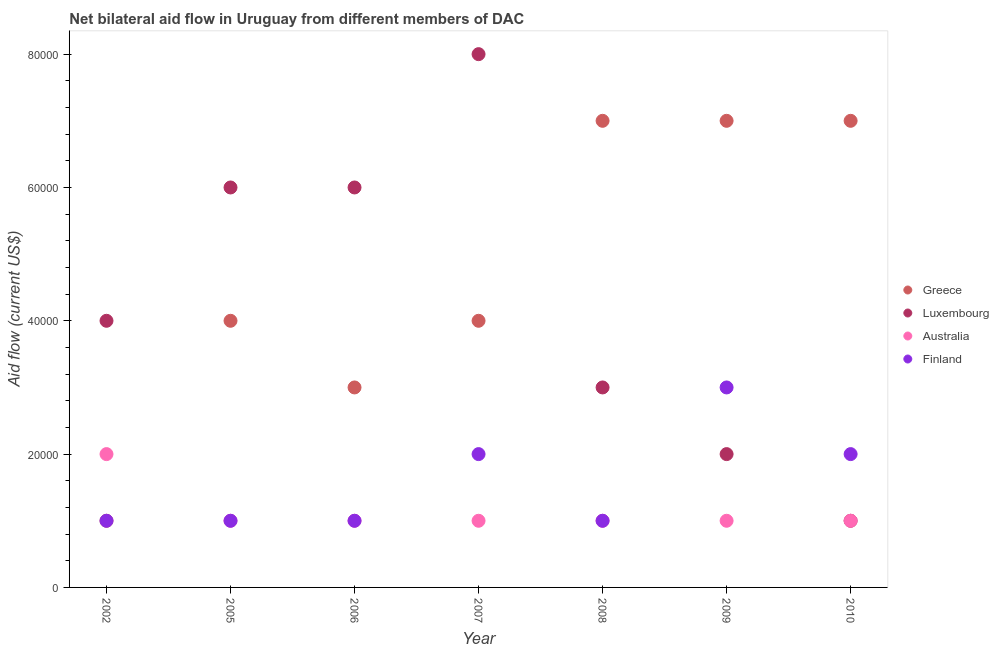What is the amount of aid given by greece in 2005?
Your response must be concise. 4.00e+04. Across all years, what is the maximum amount of aid given by australia?
Provide a succinct answer. 2.00e+04. Across all years, what is the minimum amount of aid given by luxembourg?
Give a very brief answer. 10000. What is the total amount of aid given by finland in the graph?
Your answer should be compact. 1.10e+05. What is the difference between the amount of aid given by luxembourg in 2007 and that in 2010?
Keep it short and to the point. 7.00e+04. What is the difference between the amount of aid given by finland in 2007 and the amount of aid given by greece in 2009?
Your answer should be compact. -5.00e+04. What is the average amount of aid given by luxembourg per year?
Make the answer very short. 4.29e+04. In the year 2002, what is the difference between the amount of aid given by luxembourg and amount of aid given by greece?
Your answer should be very brief. 3.00e+04. What is the ratio of the amount of aid given by greece in 2002 to that in 2006?
Make the answer very short. 0.33. Is the difference between the amount of aid given by greece in 2002 and 2005 greater than the difference between the amount of aid given by luxembourg in 2002 and 2005?
Offer a terse response. No. What is the difference between the highest and the lowest amount of aid given by greece?
Make the answer very short. 6.00e+04. Is the sum of the amount of aid given by finland in 2002 and 2009 greater than the maximum amount of aid given by australia across all years?
Make the answer very short. Yes. Is the amount of aid given by australia strictly greater than the amount of aid given by luxembourg over the years?
Offer a terse response. No. Is the amount of aid given by finland strictly less than the amount of aid given by luxembourg over the years?
Ensure brevity in your answer.  No. Are the values on the major ticks of Y-axis written in scientific E-notation?
Ensure brevity in your answer.  No. Does the graph contain any zero values?
Your answer should be compact. No. Does the graph contain grids?
Provide a short and direct response. No. How many legend labels are there?
Make the answer very short. 4. How are the legend labels stacked?
Offer a terse response. Vertical. What is the title of the graph?
Offer a terse response. Net bilateral aid flow in Uruguay from different members of DAC. What is the label or title of the Y-axis?
Give a very brief answer. Aid flow (current US$). What is the Aid flow (current US$) of Luxembourg in 2002?
Provide a succinct answer. 4.00e+04. What is the Aid flow (current US$) of Australia in 2002?
Your response must be concise. 2.00e+04. What is the Aid flow (current US$) of Australia in 2005?
Keep it short and to the point. 10000. What is the Aid flow (current US$) of Finland in 2005?
Keep it short and to the point. 10000. What is the Aid flow (current US$) in Luxembourg in 2006?
Your response must be concise. 6.00e+04. What is the Aid flow (current US$) of Australia in 2006?
Your answer should be compact. 10000. What is the Aid flow (current US$) in Greece in 2007?
Make the answer very short. 4.00e+04. What is the Aid flow (current US$) of Luxembourg in 2007?
Your answer should be compact. 8.00e+04. What is the Aid flow (current US$) in Luxembourg in 2008?
Keep it short and to the point. 3.00e+04. What is the Aid flow (current US$) in Australia in 2008?
Your answer should be very brief. 10000. What is the Aid flow (current US$) in Finland in 2008?
Keep it short and to the point. 10000. What is the Aid flow (current US$) in Finland in 2009?
Offer a terse response. 3.00e+04. What is the Aid flow (current US$) in Luxembourg in 2010?
Give a very brief answer. 10000. What is the Aid flow (current US$) of Australia in 2010?
Give a very brief answer. 10000. What is the Aid flow (current US$) of Finland in 2010?
Keep it short and to the point. 2.00e+04. Across all years, what is the maximum Aid flow (current US$) in Greece?
Your response must be concise. 7.00e+04. Across all years, what is the minimum Aid flow (current US$) in Greece?
Offer a very short reply. 10000. Across all years, what is the minimum Aid flow (current US$) of Finland?
Give a very brief answer. 10000. What is the total Aid flow (current US$) in Greece in the graph?
Ensure brevity in your answer.  3.30e+05. What is the total Aid flow (current US$) in Luxembourg in the graph?
Provide a succinct answer. 3.00e+05. What is the difference between the Aid flow (current US$) in Greece in 2002 and that in 2005?
Make the answer very short. -3.00e+04. What is the difference between the Aid flow (current US$) in Luxembourg in 2002 and that in 2005?
Keep it short and to the point. -2.00e+04. What is the difference between the Aid flow (current US$) in Australia in 2002 and that in 2005?
Keep it short and to the point. 10000. What is the difference between the Aid flow (current US$) in Finland in 2002 and that in 2005?
Ensure brevity in your answer.  0. What is the difference between the Aid flow (current US$) of Greece in 2002 and that in 2006?
Give a very brief answer. -2.00e+04. What is the difference between the Aid flow (current US$) in Australia in 2002 and that in 2006?
Ensure brevity in your answer.  10000. What is the difference between the Aid flow (current US$) in Finland in 2002 and that in 2006?
Ensure brevity in your answer.  0. What is the difference between the Aid flow (current US$) in Greece in 2002 and that in 2007?
Your answer should be compact. -3.00e+04. What is the difference between the Aid flow (current US$) of Australia in 2002 and that in 2007?
Keep it short and to the point. 10000. What is the difference between the Aid flow (current US$) in Greece in 2002 and that in 2008?
Provide a short and direct response. -6.00e+04. What is the difference between the Aid flow (current US$) in Luxembourg in 2002 and that in 2008?
Give a very brief answer. 10000. What is the difference between the Aid flow (current US$) of Finland in 2002 and that in 2008?
Provide a succinct answer. 0. What is the difference between the Aid flow (current US$) in Luxembourg in 2002 and that in 2009?
Give a very brief answer. 2.00e+04. What is the difference between the Aid flow (current US$) in Australia in 2002 and that in 2009?
Your answer should be very brief. 10000. What is the difference between the Aid flow (current US$) in Greece in 2002 and that in 2010?
Your response must be concise. -6.00e+04. What is the difference between the Aid flow (current US$) in Australia in 2002 and that in 2010?
Keep it short and to the point. 10000. What is the difference between the Aid flow (current US$) of Luxembourg in 2005 and that in 2006?
Offer a very short reply. 0. What is the difference between the Aid flow (current US$) of Luxembourg in 2005 and that in 2007?
Your response must be concise. -2.00e+04. What is the difference between the Aid flow (current US$) of Finland in 2005 and that in 2007?
Your response must be concise. -10000. What is the difference between the Aid flow (current US$) of Australia in 2005 and that in 2008?
Offer a very short reply. 0. What is the difference between the Aid flow (current US$) in Finland in 2005 and that in 2008?
Give a very brief answer. 0. What is the difference between the Aid flow (current US$) in Greece in 2005 and that in 2009?
Make the answer very short. -3.00e+04. What is the difference between the Aid flow (current US$) of Finland in 2005 and that in 2009?
Provide a succinct answer. -2.00e+04. What is the difference between the Aid flow (current US$) of Greece in 2005 and that in 2010?
Your response must be concise. -3.00e+04. What is the difference between the Aid flow (current US$) in Luxembourg in 2005 and that in 2010?
Give a very brief answer. 5.00e+04. What is the difference between the Aid flow (current US$) of Australia in 2005 and that in 2010?
Make the answer very short. 0. What is the difference between the Aid flow (current US$) in Greece in 2006 and that in 2007?
Offer a very short reply. -10000. What is the difference between the Aid flow (current US$) in Luxembourg in 2006 and that in 2007?
Make the answer very short. -2.00e+04. What is the difference between the Aid flow (current US$) of Greece in 2006 and that in 2008?
Provide a short and direct response. -4.00e+04. What is the difference between the Aid flow (current US$) of Luxembourg in 2006 and that in 2008?
Ensure brevity in your answer.  3.00e+04. What is the difference between the Aid flow (current US$) in Australia in 2006 and that in 2008?
Provide a succinct answer. 0. What is the difference between the Aid flow (current US$) in Finland in 2006 and that in 2008?
Provide a short and direct response. 0. What is the difference between the Aid flow (current US$) in Australia in 2006 and that in 2009?
Keep it short and to the point. 0. What is the difference between the Aid flow (current US$) of Finland in 2006 and that in 2009?
Keep it short and to the point. -2.00e+04. What is the difference between the Aid flow (current US$) in Greece in 2006 and that in 2010?
Your answer should be very brief. -4.00e+04. What is the difference between the Aid flow (current US$) of Luxembourg in 2006 and that in 2010?
Your answer should be compact. 5.00e+04. What is the difference between the Aid flow (current US$) of Finland in 2006 and that in 2010?
Your response must be concise. -10000. What is the difference between the Aid flow (current US$) in Luxembourg in 2007 and that in 2008?
Provide a succinct answer. 5.00e+04. What is the difference between the Aid flow (current US$) of Australia in 2007 and that in 2008?
Your answer should be very brief. 0. What is the difference between the Aid flow (current US$) of Finland in 2007 and that in 2008?
Your response must be concise. 10000. What is the difference between the Aid flow (current US$) of Australia in 2007 and that in 2009?
Offer a very short reply. 0. What is the difference between the Aid flow (current US$) in Finland in 2007 and that in 2009?
Your response must be concise. -10000. What is the difference between the Aid flow (current US$) of Luxembourg in 2007 and that in 2010?
Keep it short and to the point. 7.00e+04. What is the difference between the Aid flow (current US$) in Australia in 2007 and that in 2010?
Offer a terse response. 0. What is the difference between the Aid flow (current US$) in Luxembourg in 2008 and that in 2009?
Your answer should be very brief. 10000. What is the difference between the Aid flow (current US$) in Finland in 2008 and that in 2009?
Offer a very short reply. -2.00e+04. What is the difference between the Aid flow (current US$) of Greece in 2008 and that in 2010?
Give a very brief answer. 0. What is the difference between the Aid flow (current US$) of Australia in 2009 and that in 2010?
Give a very brief answer. 0. What is the difference between the Aid flow (current US$) in Greece in 2002 and the Aid flow (current US$) in Australia in 2005?
Your answer should be compact. 0. What is the difference between the Aid flow (current US$) in Luxembourg in 2002 and the Aid flow (current US$) in Finland in 2005?
Your answer should be very brief. 3.00e+04. What is the difference between the Aid flow (current US$) in Australia in 2002 and the Aid flow (current US$) in Finland in 2005?
Your answer should be compact. 10000. What is the difference between the Aid flow (current US$) of Greece in 2002 and the Aid flow (current US$) of Luxembourg in 2006?
Offer a terse response. -5.00e+04. What is the difference between the Aid flow (current US$) in Greece in 2002 and the Aid flow (current US$) in Australia in 2006?
Keep it short and to the point. 0. What is the difference between the Aid flow (current US$) of Australia in 2002 and the Aid flow (current US$) of Finland in 2006?
Offer a very short reply. 10000. What is the difference between the Aid flow (current US$) in Greece in 2002 and the Aid flow (current US$) in Australia in 2007?
Provide a short and direct response. 0. What is the difference between the Aid flow (current US$) of Greece in 2002 and the Aid flow (current US$) of Finland in 2007?
Make the answer very short. -10000. What is the difference between the Aid flow (current US$) of Luxembourg in 2002 and the Aid flow (current US$) of Australia in 2007?
Your answer should be compact. 3.00e+04. What is the difference between the Aid flow (current US$) in Luxembourg in 2002 and the Aid flow (current US$) in Finland in 2007?
Offer a terse response. 2.00e+04. What is the difference between the Aid flow (current US$) in Australia in 2002 and the Aid flow (current US$) in Finland in 2007?
Give a very brief answer. 0. What is the difference between the Aid flow (current US$) of Greece in 2002 and the Aid flow (current US$) of Finland in 2008?
Offer a very short reply. 0. What is the difference between the Aid flow (current US$) of Luxembourg in 2002 and the Aid flow (current US$) of Australia in 2008?
Keep it short and to the point. 3.00e+04. What is the difference between the Aid flow (current US$) of Luxembourg in 2002 and the Aid flow (current US$) of Finland in 2008?
Your response must be concise. 3.00e+04. What is the difference between the Aid flow (current US$) in Greece in 2002 and the Aid flow (current US$) in Australia in 2009?
Give a very brief answer. 0. What is the difference between the Aid flow (current US$) in Greece in 2002 and the Aid flow (current US$) in Finland in 2009?
Your answer should be compact. -2.00e+04. What is the difference between the Aid flow (current US$) in Luxembourg in 2002 and the Aid flow (current US$) in Finland in 2009?
Ensure brevity in your answer.  10000. What is the difference between the Aid flow (current US$) in Australia in 2002 and the Aid flow (current US$) in Finland in 2009?
Offer a terse response. -10000. What is the difference between the Aid flow (current US$) in Greece in 2002 and the Aid flow (current US$) in Luxembourg in 2010?
Make the answer very short. 0. What is the difference between the Aid flow (current US$) in Greece in 2002 and the Aid flow (current US$) in Finland in 2010?
Your response must be concise. -10000. What is the difference between the Aid flow (current US$) in Luxembourg in 2002 and the Aid flow (current US$) in Australia in 2010?
Offer a very short reply. 3.00e+04. What is the difference between the Aid flow (current US$) of Australia in 2002 and the Aid flow (current US$) of Finland in 2010?
Your answer should be very brief. 0. What is the difference between the Aid flow (current US$) of Greece in 2005 and the Aid flow (current US$) of Luxembourg in 2006?
Your answer should be very brief. -2.00e+04. What is the difference between the Aid flow (current US$) of Greece in 2005 and the Aid flow (current US$) of Australia in 2006?
Give a very brief answer. 3.00e+04. What is the difference between the Aid flow (current US$) in Australia in 2005 and the Aid flow (current US$) in Finland in 2006?
Your response must be concise. 0. What is the difference between the Aid flow (current US$) of Greece in 2005 and the Aid flow (current US$) of Finland in 2007?
Offer a terse response. 2.00e+04. What is the difference between the Aid flow (current US$) of Luxembourg in 2005 and the Aid flow (current US$) of Finland in 2007?
Keep it short and to the point. 4.00e+04. What is the difference between the Aid flow (current US$) in Greece in 2005 and the Aid flow (current US$) in Luxembourg in 2008?
Provide a succinct answer. 10000. What is the difference between the Aid flow (current US$) of Greece in 2005 and the Aid flow (current US$) of Australia in 2008?
Your response must be concise. 3.00e+04. What is the difference between the Aid flow (current US$) of Greece in 2005 and the Aid flow (current US$) of Finland in 2008?
Your answer should be compact. 3.00e+04. What is the difference between the Aid flow (current US$) of Luxembourg in 2005 and the Aid flow (current US$) of Australia in 2008?
Your answer should be compact. 5.00e+04. What is the difference between the Aid flow (current US$) in Luxembourg in 2005 and the Aid flow (current US$) in Finland in 2008?
Give a very brief answer. 5.00e+04. What is the difference between the Aid flow (current US$) in Luxembourg in 2005 and the Aid flow (current US$) in Australia in 2009?
Your answer should be compact. 5.00e+04. What is the difference between the Aid flow (current US$) of Luxembourg in 2005 and the Aid flow (current US$) of Finland in 2009?
Ensure brevity in your answer.  3.00e+04. What is the difference between the Aid flow (current US$) of Australia in 2005 and the Aid flow (current US$) of Finland in 2009?
Offer a terse response. -2.00e+04. What is the difference between the Aid flow (current US$) in Greece in 2005 and the Aid flow (current US$) in Finland in 2010?
Offer a very short reply. 2.00e+04. What is the difference between the Aid flow (current US$) in Luxembourg in 2005 and the Aid flow (current US$) in Australia in 2010?
Make the answer very short. 5.00e+04. What is the difference between the Aid flow (current US$) in Luxembourg in 2005 and the Aid flow (current US$) in Finland in 2010?
Provide a succinct answer. 4.00e+04. What is the difference between the Aid flow (current US$) in Australia in 2005 and the Aid flow (current US$) in Finland in 2010?
Provide a succinct answer. -10000. What is the difference between the Aid flow (current US$) of Greece in 2006 and the Aid flow (current US$) of Luxembourg in 2007?
Keep it short and to the point. -5.00e+04. What is the difference between the Aid flow (current US$) in Greece in 2006 and the Aid flow (current US$) in Finland in 2007?
Your answer should be compact. 10000. What is the difference between the Aid flow (current US$) in Luxembourg in 2006 and the Aid flow (current US$) in Australia in 2007?
Make the answer very short. 5.00e+04. What is the difference between the Aid flow (current US$) of Luxembourg in 2006 and the Aid flow (current US$) of Finland in 2007?
Give a very brief answer. 4.00e+04. What is the difference between the Aid flow (current US$) in Greece in 2006 and the Aid flow (current US$) in Luxembourg in 2008?
Offer a terse response. 0. What is the difference between the Aid flow (current US$) in Greece in 2006 and the Aid flow (current US$) in Finland in 2008?
Offer a terse response. 2.00e+04. What is the difference between the Aid flow (current US$) of Luxembourg in 2006 and the Aid flow (current US$) of Australia in 2008?
Ensure brevity in your answer.  5.00e+04. What is the difference between the Aid flow (current US$) in Luxembourg in 2006 and the Aid flow (current US$) in Finland in 2008?
Give a very brief answer. 5.00e+04. What is the difference between the Aid flow (current US$) of Australia in 2006 and the Aid flow (current US$) of Finland in 2008?
Make the answer very short. 0. What is the difference between the Aid flow (current US$) of Greece in 2006 and the Aid flow (current US$) of Luxembourg in 2009?
Keep it short and to the point. 10000. What is the difference between the Aid flow (current US$) of Greece in 2006 and the Aid flow (current US$) of Finland in 2009?
Provide a succinct answer. 0. What is the difference between the Aid flow (current US$) of Luxembourg in 2006 and the Aid flow (current US$) of Australia in 2009?
Make the answer very short. 5.00e+04. What is the difference between the Aid flow (current US$) in Greece in 2006 and the Aid flow (current US$) in Australia in 2010?
Give a very brief answer. 2.00e+04. What is the difference between the Aid flow (current US$) in Greece in 2006 and the Aid flow (current US$) in Finland in 2010?
Make the answer very short. 10000. What is the difference between the Aid flow (current US$) of Greece in 2007 and the Aid flow (current US$) of Luxembourg in 2008?
Your answer should be very brief. 10000. What is the difference between the Aid flow (current US$) of Luxembourg in 2007 and the Aid flow (current US$) of Australia in 2008?
Keep it short and to the point. 7.00e+04. What is the difference between the Aid flow (current US$) of Greece in 2007 and the Aid flow (current US$) of Luxembourg in 2009?
Your response must be concise. 2.00e+04. What is the difference between the Aid flow (current US$) in Greece in 2007 and the Aid flow (current US$) in Finland in 2009?
Provide a succinct answer. 10000. What is the difference between the Aid flow (current US$) of Luxembourg in 2007 and the Aid flow (current US$) of Australia in 2009?
Provide a succinct answer. 7.00e+04. What is the difference between the Aid flow (current US$) of Luxembourg in 2007 and the Aid flow (current US$) of Finland in 2009?
Your response must be concise. 5.00e+04. What is the difference between the Aid flow (current US$) in Greece in 2007 and the Aid flow (current US$) in Australia in 2010?
Give a very brief answer. 3.00e+04. What is the difference between the Aid flow (current US$) of Greece in 2007 and the Aid flow (current US$) of Finland in 2010?
Provide a succinct answer. 2.00e+04. What is the difference between the Aid flow (current US$) in Luxembourg in 2007 and the Aid flow (current US$) in Australia in 2010?
Offer a very short reply. 7.00e+04. What is the difference between the Aid flow (current US$) in Luxembourg in 2007 and the Aid flow (current US$) in Finland in 2010?
Offer a very short reply. 6.00e+04. What is the difference between the Aid flow (current US$) of Australia in 2007 and the Aid flow (current US$) of Finland in 2010?
Your response must be concise. -10000. What is the difference between the Aid flow (current US$) in Luxembourg in 2008 and the Aid flow (current US$) in Finland in 2009?
Provide a succinct answer. 0. What is the difference between the Aid flow (current US$) of Greece in 2008 and the Aid flow (current US$) of Luxembourg in 2010?
Your response must be concise. 6.00e+04. What is the difference between the Aid flow (current US$) in Greece in 2008 and the Aid flow (current US$) in Australia in 2010?
Offer a very short reply. 6.00e+04. What is the difference between the Aid flow (current US$) in Greece in 2008 and the Aid flow (current US$) in Finland in 2010?
Give a very brief answer. 5.00e+04. What is the difference between the Aid flow (current US$) of Luxembourg in 2008 and the Aid flow (current US$) of Finland in 2010?
Provide a succinct answer. 10000. What is the difference between the Aid flow (current US$) of Australia in 2008 and the Aid flow (current US$) of Finland in 2010?
Give a very brief answer. -10000. What is the difference between the Aid flow (current US$) in Greece in 2009 and the Aid flow (current US$) in Australia in 2010?
Give a very brief answer. 6.00e+04. What is the difference between the Aid flow (current US$) in Luxembourg in 2009 and the Aid flow (current US$) in Finland in 2010?
Your response must be concise. 0. What is the difference between the Aid flow (current US$) in Australia in 2009 and the Aid flow (current US$) in Finland in 2010?
Provide a short and direct response. -10000. What is the average Aid flow (current US$) in Greece per year?
Provide a succinct answer. 4.71e+04. What is the average Aid flow (current US$) of Luxembourg per year?
Your response must be concise. 4.29e+04. What is the average Aid flow (current US$) of Australia per year?
Offer a terse response. 1.14e+04. What is the average Aid flow (current US$) of Finland per year?
Ensure brevity in your answer.  1.57e+04. In the year 2002, what is the difference between the Aid flow (current US$) in Luxembourg and Aid flow (current US$) in Australia?
Keep it short and to the point. 2.00e+04. In the year 2002, what is the difference between the Aid flow (current US$) of Australia and Aid flow (current US$) of Finland?
Provide a succinct answer. 10000. In the year 2005, what is the difference between the Aid flow (current US$) of Greece and Aid flow (current US$) of Luxembourg?
Your answer should be compact. -2.00e+04. In the year 2006, what is the difference between the Aid flow (current US$) of Greece and Aid flow (current US$) of Luxembourg?
Provide a short and direct response. -3.00e+04. In the year 2006, what is the difference between the Aid flow (current US$) in Greece and Aid flow (current US$) in Finland?
Give a very brief answer. 2.00e+04. In the year 2006, what is the difference between the Aid flow (current US$) in Luxembourg and Aid flow (current US$) in Finland?
Your answer should be compact. 5.00e+04. In the year 2006, what is the difference between the Aid flow (current US$) of Australia and Aid flow (current US$) of Finland?
Keep it short and to the point. 0. In the year 2007, what is the difference between the Aid flow (current US$) of Greece and Aid flow (current US$) of Luxembourg?
Keep it short and to the point. -4.00e+04. In the year 2007, what is the difference between the Aid flow (current US$) in Luxembourg and Aid flow (current US$) in Australia?
Ensure brevity in your answer.  7.00e+04. In the year 2007, what is the difference between the Aid flow (current US$) of Luxembourg and Aid flow (current US$) of Finland?
Provide a succinct answer. 6.00e+04. In the year 2007, what is the difference between the Aid flow (current US$) in Australia and Aid flow (current US$) in Finland?
Give a very brief answer. -10000. In the year 2008, what is the difference between the Aid flow (current US$) in Greece and Aid flow (current US$) in Luxembourg?
Your answer should be compact. 4.00e+04. In the year 2008, what is the difference between the Aid flow (current US$) in Greece and Aid flow (current US$) in Australia?
Provide a short and direct response. 6.00e+04. In the year 2008, what is the difference between the Aid flow (current US$) in Luxembourg and Aid flow (current US$) in Australia?
Provide a short and direct response. 2.00e+04. In the year 2009, what is the difference between the Aid flow (current US$) in Greece and Aid flow (current US$) in Luxembourg?
Offer a very short reply. 5.00e+04. In the year 2009, what is the difference between the Aid flow (current US$) in Greece and Aid flow (current US$) in Australia?
Keep it short and to the point. 6.00e+04. In the year 2009, what is the difference between the Aid flow (current US$) in Greece and Aid flow (current US$) in Finland?
Provide a short and direct response. 4.00e+04. In the year 2009, what is the difference between the Aid flow (current US$) of Australia and Aid flow (current US$) of Finland?
Your answer should be compact. -2.00e+04. In the year 2010, what is the difference between the Aid flow (current US$) in Greece and Aid flow (current US$) in Luxembourg?
Give a very brief answer. 6.00e+04. In the year 2010, what is the difference between the Aid flow (current US$) in Greece and Aid flow (current US$) in Australia?
Provide a succinct answer. 6.00e+04. In the year 2010, what is the difference between the Aid flow (current US$) in Luxembourg and Aid flow (current US$) in Australia?
Give a very brief answer. 0. In the year 2010, what is the difference between the Aid flow (current US$) in Luxembourg and Aid flow (current US$) in Finland?
Make the answer very short. -10000. In the year 2010, what is the difference between the Aid flow (current US$) in Australia and Aid flow (current US$) in Finland?
Ensure brevity in your answer.  -10000. What is the ratio of the Aid flow (current US$) in Australia in 2002 to that in 2005?
Ensure brevity in your answer.  2. What is the ratio of the Aid flow (current US$) in Finland in 2002 to that in 2005?
Your response must be concise. 1. What is the ratio of the Aid flow (current US$) of Australia in 2002 to that in 2006?
Keep it short and to the point. 2. What is the ratio of the Aid flow (current US$) of Finland in 2002 to that in 2006?
Your answer should be compact. 1. What is the ratio of the Aid flow (current US$) of Luxembourg in 2002 to that in 2007?
Provide a succinct answer. 0.5. What is the ratio of the Aid flow (current US$) of Greece in 2002 to that in 2008?
Offer a terse response. 0.14. What is the ratio of the Aid flow (current US$) in Luxembourg in 2002 to that in 2008?
Make the answer very short. 1.33. What is the ratio of the Aid flow (current US$) in Greece in 2002 to that in 2009?
Provide a succinct answer. 0.14. What is the ratio of the Aid flow (current US$) of Greece in 2002 to that in 2010?
Your response must be concise. 0.14. What is the ratio of the Aid flow (current US$) of Luxembourg in 2002 to that in 2010?
Your answer should be compact. 4. What is the ratio of the Aid flow (current US$) in Australia in 2002 to that in 2010?
Offer a very short reply. 2. What is the ratio of the Aid flow (current US$) of Finland in 2002 to that in 2010?
Your answer should be compact. 0.5. What is the ratio of the Aid flow (current US$) in Luxembourg in 2005 to that in 2006?
Make the answer very short. 1. What is the ratio of the Aid flow (current US$) in Finland in 2005 to that in 2006?
Offer a very short reply. 1. What is the ratio of the Aid flow (current US$) of Greece in 2005 to that in 2007?
Make the answer very short. 1. What is the ratio of the Aid flow (current US$) in Finland in 2005 to that in 2007?
Your response must be concise. 0.5. What is the ratio of the Aid flow (current US$) of Greece in 2005 to that in 2008?
Your answer should be compact. 0.57. What is the ratio of the Aid flow (current US$) in Luxembourg in 2005 to that in 2008?
Offer a very short reply. 2. What is the ratio of the Aid flow (current US$) in Finland in 2005 to that in 2008?
Ensure brevity in your answer.  1. What is the ratio of the Aid flow (current US$) of Greece in 2005 to that in 2009?
Your answer should be very brief. 0.57. What is the ratio of the Aid flow (current US$) in Australia in 2005 to that in 2009?
Give a very brief answer. 1. What is the ratio of the Aid flow (current US$) of Luxembourg in 2005 to that in 2010?
Your answer should be very brief. 6. What is the ratio of the Aid flow (current US$) of Luxembourg in 2006 to that in 2007?
Provide a short and direct response. 0.75. What is the ratio of the Aid flow (current US$) in Australia in 2006 to that in 2007?
Offer a terse response. 1. What is the ratio of the Aid flow (current US$) in Greece in 2006 to that in 2008?
Make the answer very short. 0.43. What is the ratio of the Aid flow (current US$) in Luxembourg in 2006 to that in 2008?
Provide a succinct answer. 2. What is the ratio of the Aid flow (current US$) of Greece in 2006 to that in 2009?
Your answer should be very brief. 0.43. What is the ratio of the Aid flow (current US$) in Luxembourg in 2006 to that in 2009?
Ensure brevity in your answer.  3. What is the ratio of the Aid flow (current US$) in Australia in 2006 to that in 2009?
Make the answer very short. 1. What is the ratio of the Aid flow (current US$) in Greece in 2006 to that in 2010?
Make the answer very short. 0.43. What is the ratio of the Aid flow (current US$) of Luxembourg in 2006 to that in 2010?
Ensure brevity in your answer.  6. What is the ratio of the Aid flow (current US$) of Luxembourg in 2007 to that in 2008?
Your answer should be very brief. 2.67. What is the ratio of the Aid flow (current US$) of Greece in 2007 to that in 2009?
Give a very brief answer. 0.57. What is the ratio of the Aid flow (current US$) of Luxembourg in 2007 to that in 2009?
Provide a succinct answer. 4. What is the ratio of the Aid flow (current US$) in Greece in 2007 to that in 2010?
Offer a terse response. 0.57. What is the ratio of the Aid flow (current US$) in Luxembourg in 2007 to that in 2010?
Offer a terse response. 8. What is the ratio of the Aid flow (current US$) in Australia in 2007 to that in 2010?
Ensure brevity in your answer.  1. What is the ratio of the Aid flow (current US$) of Finland in 2007 to that in 2010?
Offer a very short reply. 1. What is the ratio of the Aid flow (current US$) in Finland in 2008 to that in 2009?
Your answer should be compact. 0.33. What is the ratio of the Aid flow (current US$) of Luxembourg in 2008 to that in 2010?
Your answer should be compact. 3. What is the ratio of the Aid flow (current US$) of Greece in 2009 to that in 2010?
Ensure brevity in your answer.  1. What is the ratio of the Aid flow (current US$) of Luxembourg in 2009 to that in 2010?
Offer a terse response. 2. What is the ratio of the Aid flow (current US$) of Australia in 2009 to that in 2010?
Give a very brief answer. 1. What is the ratio of the Aid flow (current US$) in Finland in 2009 to that in 2010?
Provide a short and direct response. 1.5. What is the difference between the highest and the second highest Aid flow (current US$) in Greece?
Offer a very short reply. 0. What is the difference between the highest and the second highest Aid flow (current US$) in Luxembourg?
Provide a succinct answer. 2.00e+04. What is the difference between the highest and the second highest Aid flow (current US$) in Australia?
Provide a short and direct response. 10000. What is the difference between the highest and the second highest Aid flow (current US$) of Finland?
Provide a short and direct response. 10000. What is the difference between the highest and the lowest Aid flow (current US$) in Luxembourg?
Keep it short and to the point. 7.00e+04. What is the difference between the highest and the lowest Aid flow (current US$) in Australia?
Ensure brevity in your answer.  10000. 